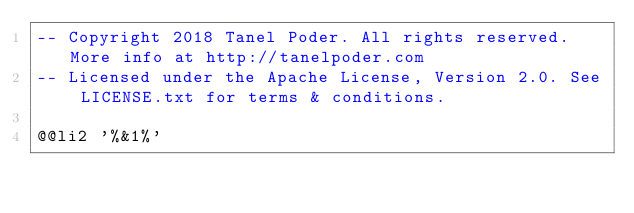Convert code to text. <code><loc_0><loc_0><loc_500><loc_500><_SQL_>-- Copyright 2018 Tanel Poder. All rights reserved. More info at http://tanelpoder.com
-- Licensed under the Apache License, Version 2.0. See LICENSE.txt for terms & conditions.

@@li2 '%&1%'</code> 